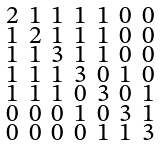<formula> <loc_0><loc_0><loc_500><loc_500>\begin{smallmatrix} 2 & 1 & 1 & 1 & 1 & 0 & 0 \\ 1 & 2 & 1 & 1 & 1 & 0 & 0 \\ 1 & 1 & 3 & 1 & 1 & 0 & 0 \\ 1 & 1 & 1 & 3 & 0 & 1 & 0 \\ 1 & 1 & 1 & 0 & 3 & 0 & 1 \\ 0 & 0 & 0 & 1 & 0 & 3 & 1 \\ 0 & 0 & 0 & 0 & 1 & 1 & 3 \end{smallmatrix}</formula> 